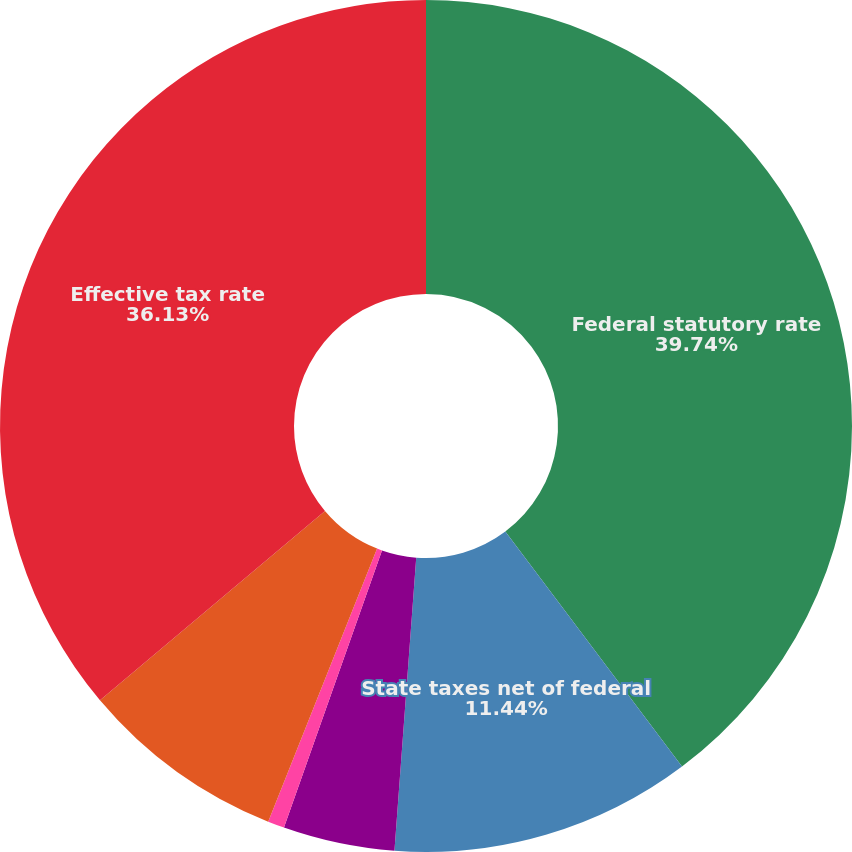Convert chart to OTSL. <chart><loc_0><loc_0><loc_500><loc_500><pie_chart><fcel>Federal statutory rate<fcel>State taxes net of federal<fcel>Divestiture gain<fcel>Other items<fcel>Impact of income attributable<fcel>Effective tax rate<nl><fcel>39.74%<fcel>11.44%<fcel>4.23%<fcel>0.63%<fcel>7.83%<fcel>36.13%<nl></chart> 